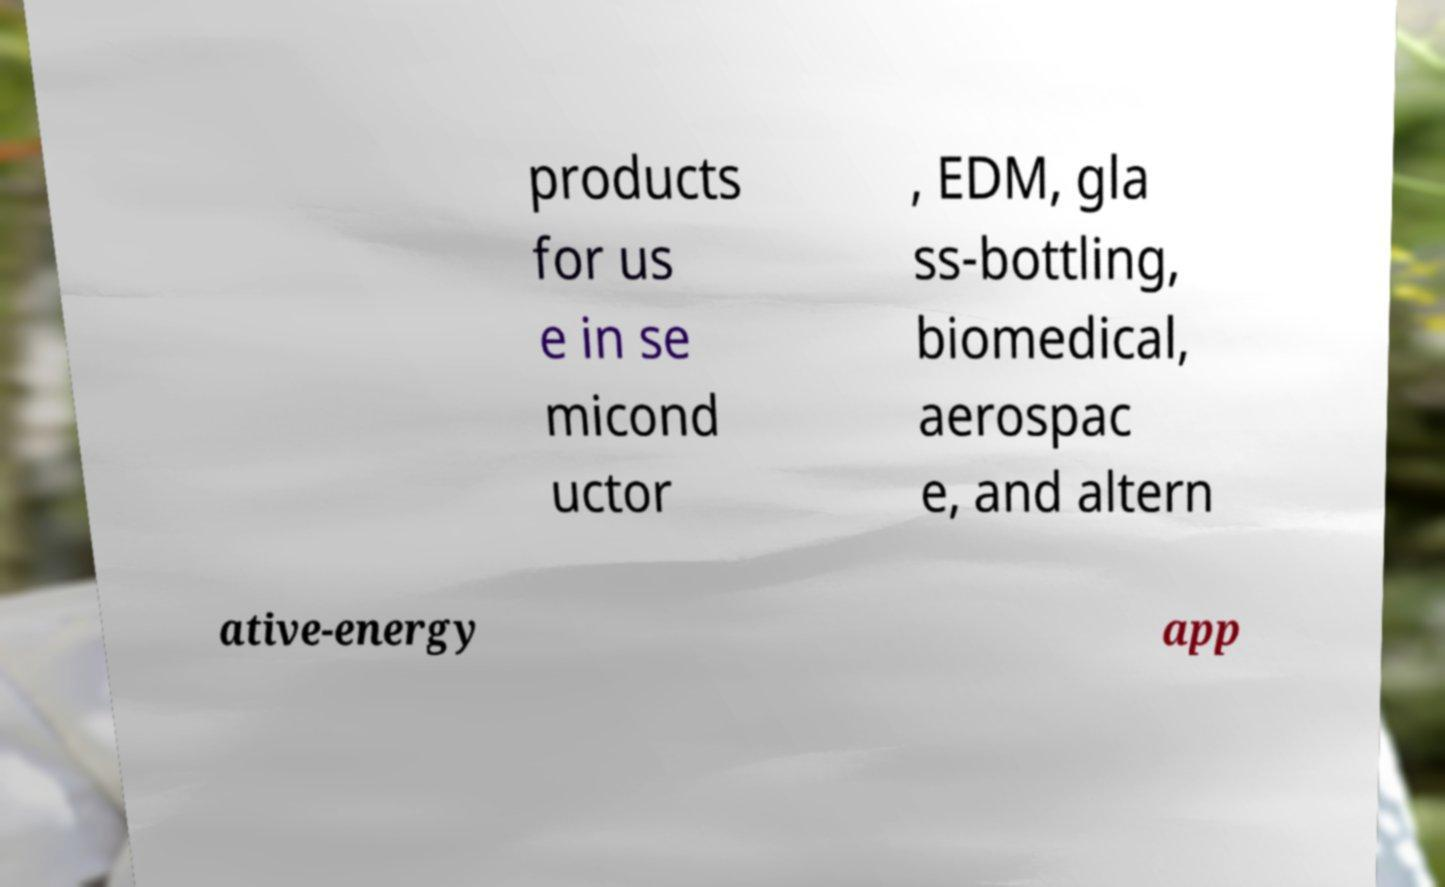For documentation purposes, I need the text within this image transcribed. Could you provide that? products for us e in se micond uctor , EDM, gla ss-bottling, biomedical, aerospac e, and altern ative-energy app 